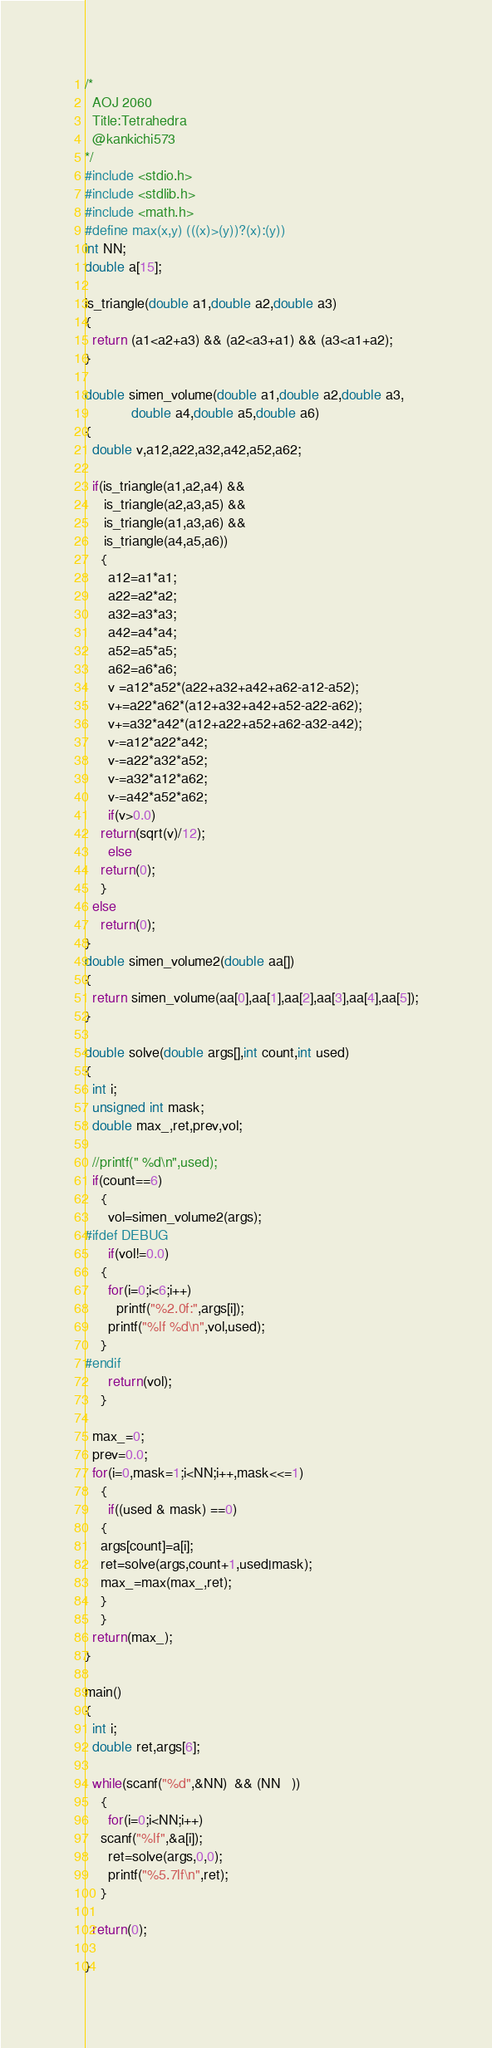Convert code to text. <code><loc_0><loc_0><loc_500><loc_500><_C_>/*
  AOJ 2060
  Title:Tetrahedra
  @kankichi573
*/
#include <stdio.h>
#include <stdlib.h>
#include <math.h>
#define max(x,y) (((x)>(y))?(x):(y))
int NN;
double a[15];

is_triangle(double a1,double a2,double a3)
{
  return (a1<a2+a3) && (a2<a3+a1) && (a3<a1+a2);
}

double simen_volume(double a1,double a2,double a3,
		    double a4,double a5,double a6)
{
  double v,a12,a22,a32,a42,a52,a62;

  if(is_triangle(a1,a2,a4) &&
     is_triangle(a2,a3,a5) &&
     is_triangle(a1,a3,a6) &&
     is_triangle(a4,a5,a6))
    {
      a12=a1*a1;
      a22=a2*a2;
      a32=a3*a3;
      a42=a4*a4;
      a52=a5*a5;
      a62=a6*a6;
      v =a12*a52*(a22+a32+a42+a62-a12-a52);
      v+=a22*a62*(a12+a32+a42+a52-a22-a62);
      v+=a32*a42*(a12+a22+a52+a62-a32-a42);
      v-=a12*a22*a42;
      v-=a22*a32*a52;
      v-=a32*a12*a62;
      v-=a42*a52*a62;
      if(v>0.0)
	return(sqrt(v)/12);
      else
	return(0);
    }
  else
    return(0);
}
double simen_volume2(double aa[])
{
  return simen_volume(aa[0],aa[1],aa[2],aa[3],aa[4],aa[5]);
}

double solve(double args[],int count,int used)
{
  int i;
  unsigned int mask;
  double max_,ret,prev,vol;

  //printf(" %d\n",used);
  if(count==6)
    {
      vol=simen_volume2(args);
#ifdef DEBUG
      if(vol!=0.0)
	{
	  for(i=0;i<6;i++)
	    printf("%2.0f:",args[i]);
	  printf("%lf %d\n",vol,used);
	}
#endif
      return(vol);
    }

  max_=0;
  prev=0.0;
  for(i=0,mask=1;i<NN;i++,mask<<=1)
    {
      if((used & mask) ==0)
	{
	args[count]=a[i];
	ret=solve(args,count+1,used|mask);
	max_=max(max_,ret);
	}
    }
  return(max_);
}

main()
{
  int i;
  double ret,args[6];

  while(scanf("%d",&NN)  && (NN   ))
    {
      for(i=0;i<NN;i++)
	scanf("%lf",&a[i]);
      ret=solve(args,0,0);
      printf("%5.7lf\n",ret);
    }
  
  return(0);

}</code> 